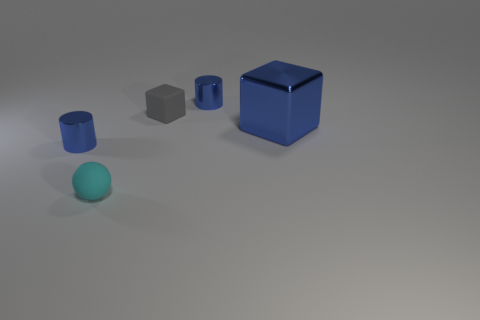Add 1 blue cylinders. How many objects exist? 6 Subtract all blocks. How many objects are left? 3 Subtract all rubber cubes. Subtract all small blocks. How many objects are left? 3 Add 3 small blue objects. How many small blue objects are left? 5 Add 3 small brown cylinders. How many small brown cylinders exist? 3 Subtract 0 purple cylinders. How many objects are left? 5 